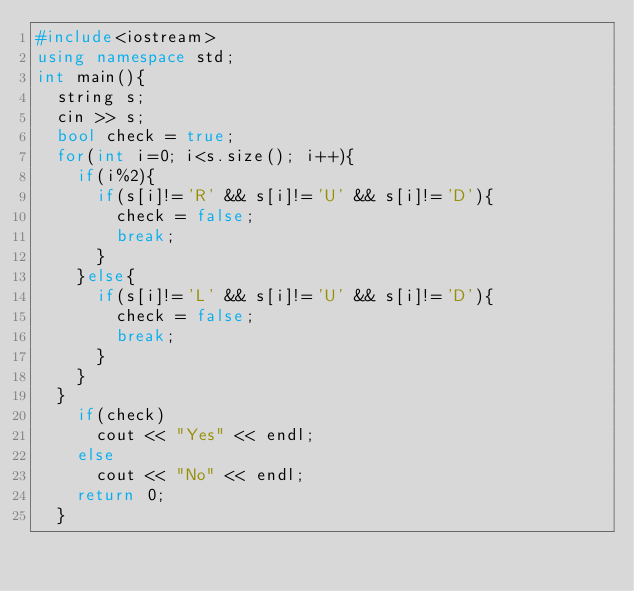Convert code to text. <code><loc_0><loc_0><loc_500><loc_500><_C++_>#include<iostream>
using namespace std;
int main(){
  string s;
  cin >> s;
  bool check = true;
  for(int i=0; i<s.size(); i++){
    if(i%2){
      if(s[i]!='R' && s[i]!='U' && s[i]!='D'){
        check = false;
        break;
      }
    }else{
      if(s[i]!='L' && s[i]!='U' && s[i]!='D'){
        check = false;
        break;
      }
    }
  }
    if(check)
      cout << "Yes" << endl;
    else
      cout << "No" << endl;
    return 0;
  }</code> 